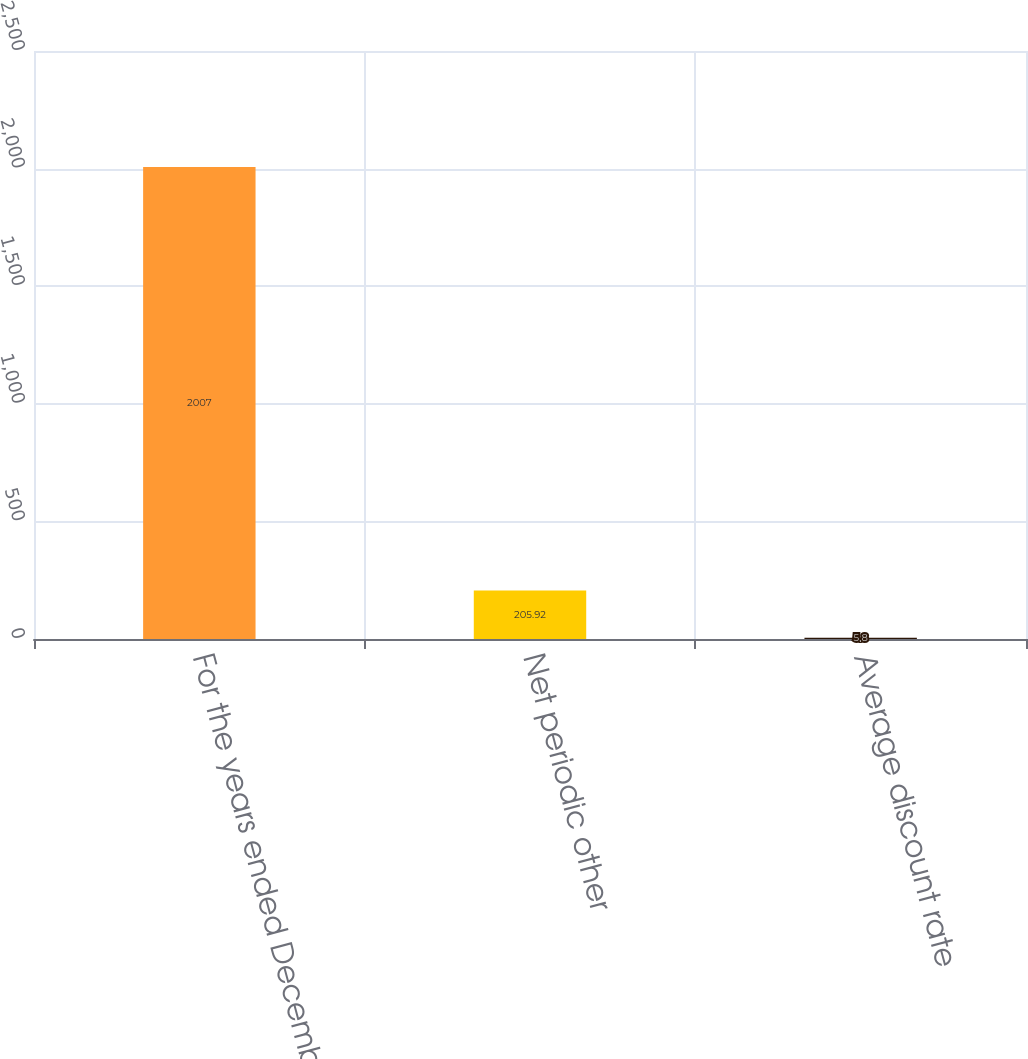Convert chart to OTSL. <chart><loc_0><loc_0><loc_500><loc_500><bar_chart><fcel>For the years ended December<fcel>Net periodic other<fcel>Average discount rate<nl><fcel>2007<fcel>205.92<fcel>5.8<nl></chart> 